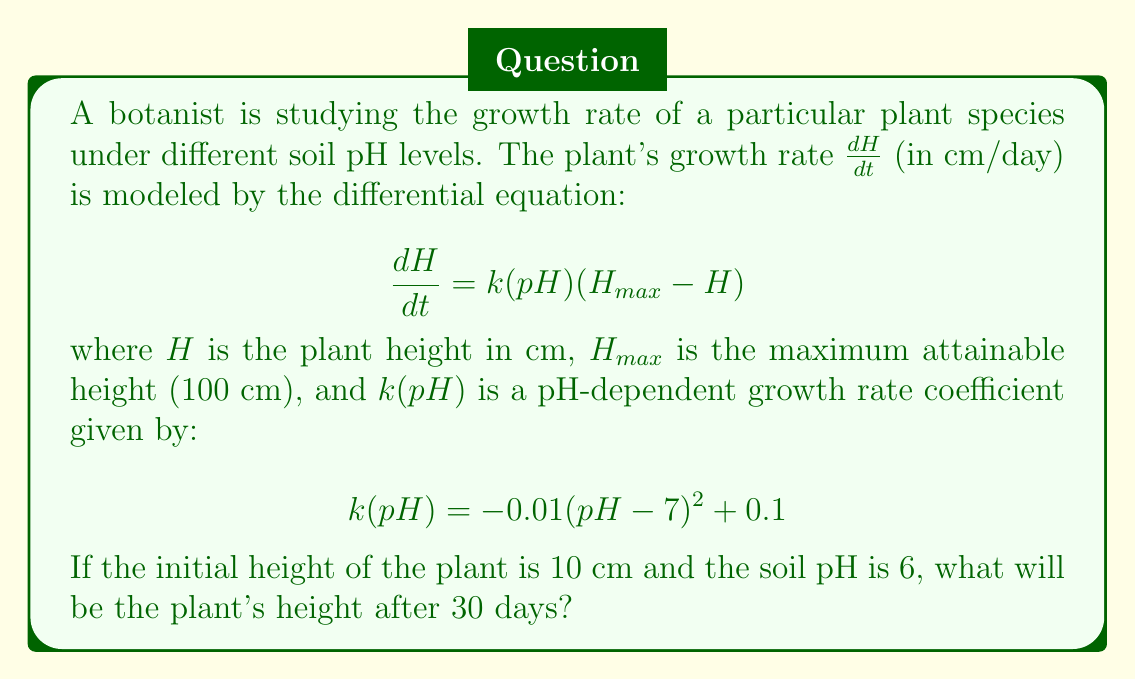Can you solve this math problem? To solve this problem, we need to follow these steps:

1) First, let's determine the value of $k(pH)$ for pH = 6:
   $$k(6) = -0.01(6-7)^2 + 0.1 = -0.01(-1)^2 + 0.1 = 0.09$$

2) Now our differential equation becomes:
   $$\frac{dH}{dt} = 0.09(100 - H)$$

3) This is a separable differential equation. We can solve it as follows:
   $$\frac{dH}{100 - H} = 0.09dt$$

4) Integrating both sides:
   $$-\ln|100 - H| = 0.09t + C$$

5) Using the initial condition $H(0) = 10$, we can find $C$:
   $$-\ln|100 - 10| = 0 + C$$
   $$C = -\ln(90) = -4.5$$

6) Substituting back:
   $$-\ln|100 - H| = 0.09t - 4.5$$

7) Solving for $H$:
   $$\ln|100 - H| = 4.5 - 0.09t$$
   $$100 - H = e^{4.5 - 0.09t}$$
   $$H = 100 - e^{4.5 - 0.09t}$$

8) Now we can find $H(30)$:
   $$H(30) = 100 - e^{4.5 - 0.09(30)}$$
   $$= 100 - e^{4.5 - 2.7}$$
   $$= 100 - e^{1.8}$$
   $$\approx 93.95 \text{ cm}$$

Therefore, after 30 days, the plant's height will be approximately 93.95 cm.
Answer: 93.95 cm 